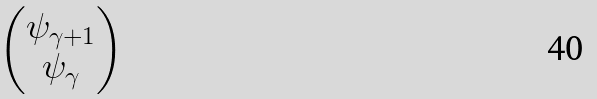<formula> <loc_0><loc_0><loc_500><loc_500>\begin{pmatrix} \psi _ { \gamma + 1 } \\ \psi _ { \gamma } \end{pmatrix}</formula> 